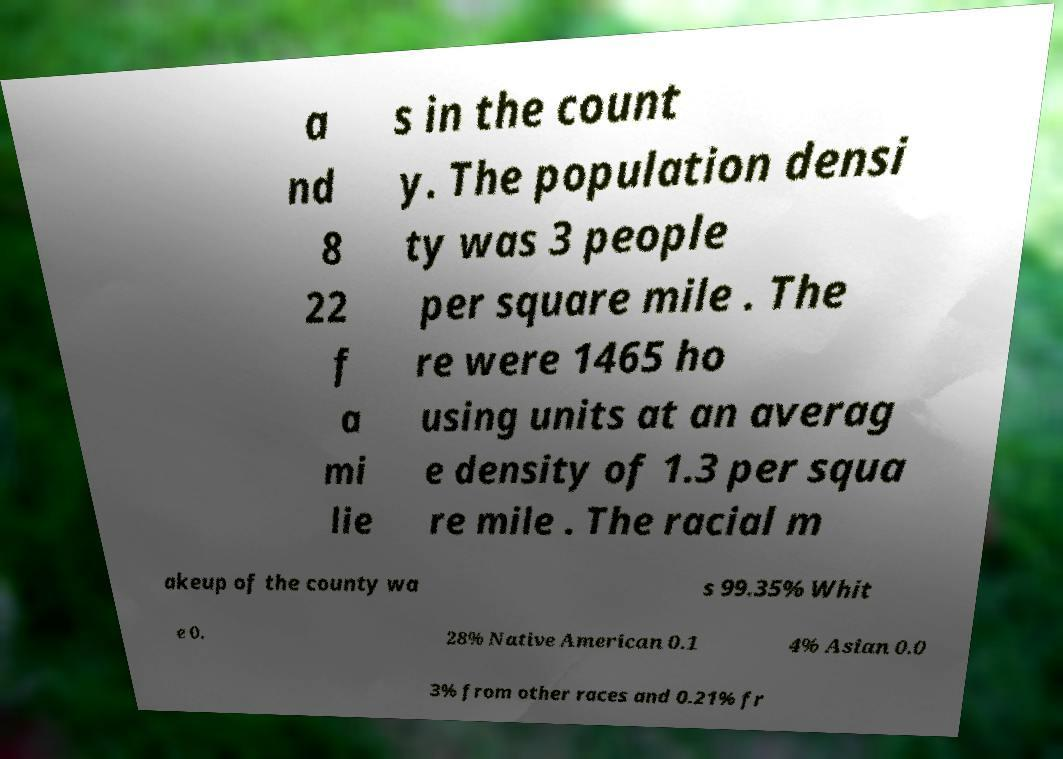Please read and relay the text visible in this image. What does it say? a nd 8 22 f a mi lie s in the count y. The population densi ty was 3 people per square mile . The re were 1465 ho using units at an averag e density of 1.3 per squa re mile . The racial m akeup of the county wa s 99.35% Whit e 0. 28% Native American 0.1 4% Asian 0.0 3% from other races and 0.21% fr 